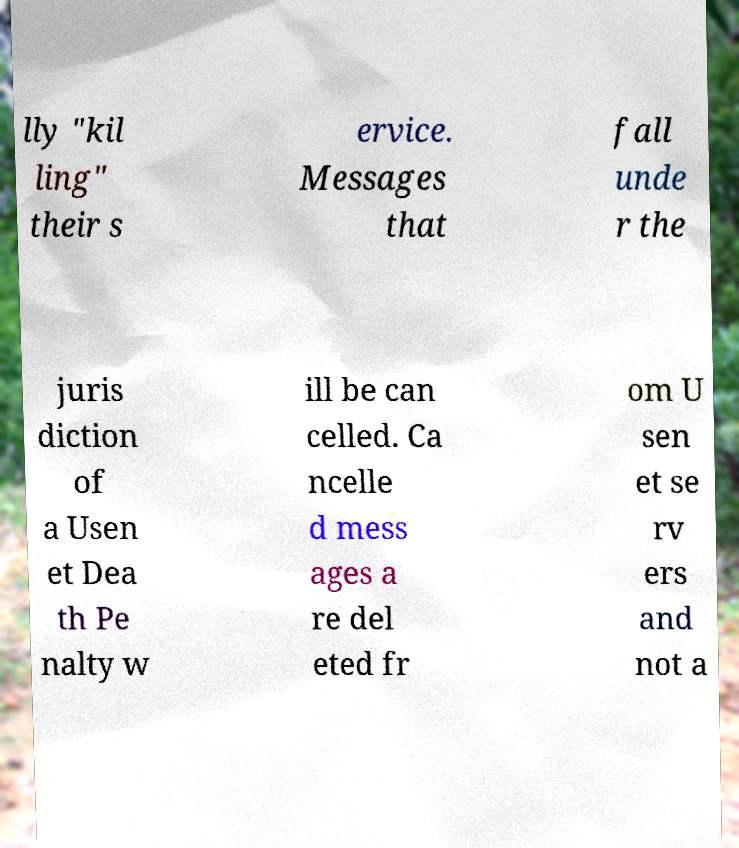Could you extract and type out the text from this image? lly "kil ling" their s ervice. Messages that fall unde r the juris diction of a Usen et Dea th Pe nalty w ill be can celled. Ca ncelle d mess ages a re del eted fr om U sen et se rv ers and not a 